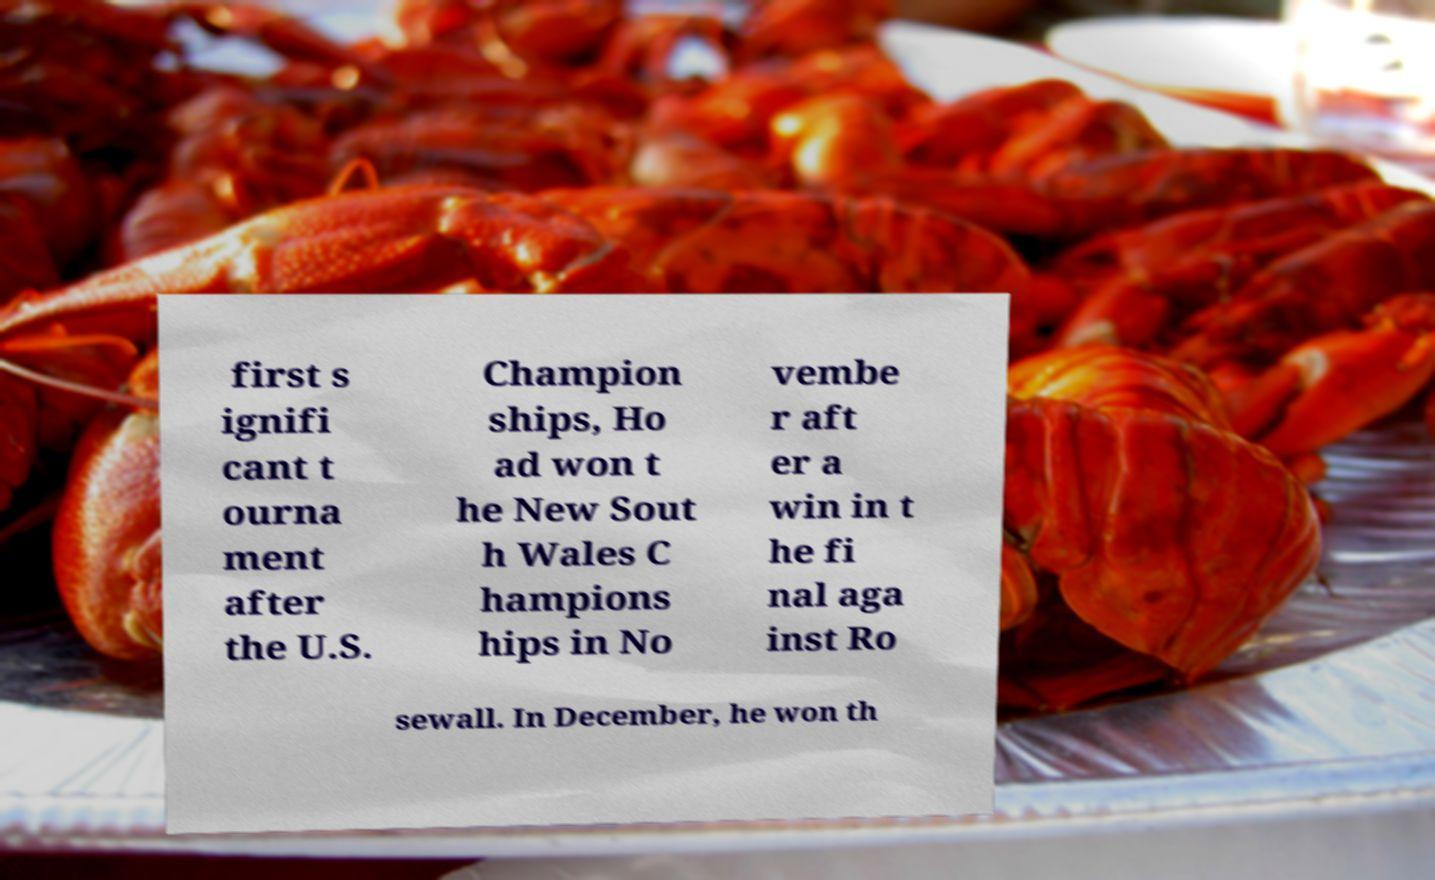For documentation purposes, I need the text within this image transcribed. Could you provide that? first s ignifi cant t ourna ment after the U.S. Champion ships, Ho ad won t he New Sout h Wales C hampions hips in No vembe r aft er a win in t he fi nal aga inst Ro sewall. In December, he won th 